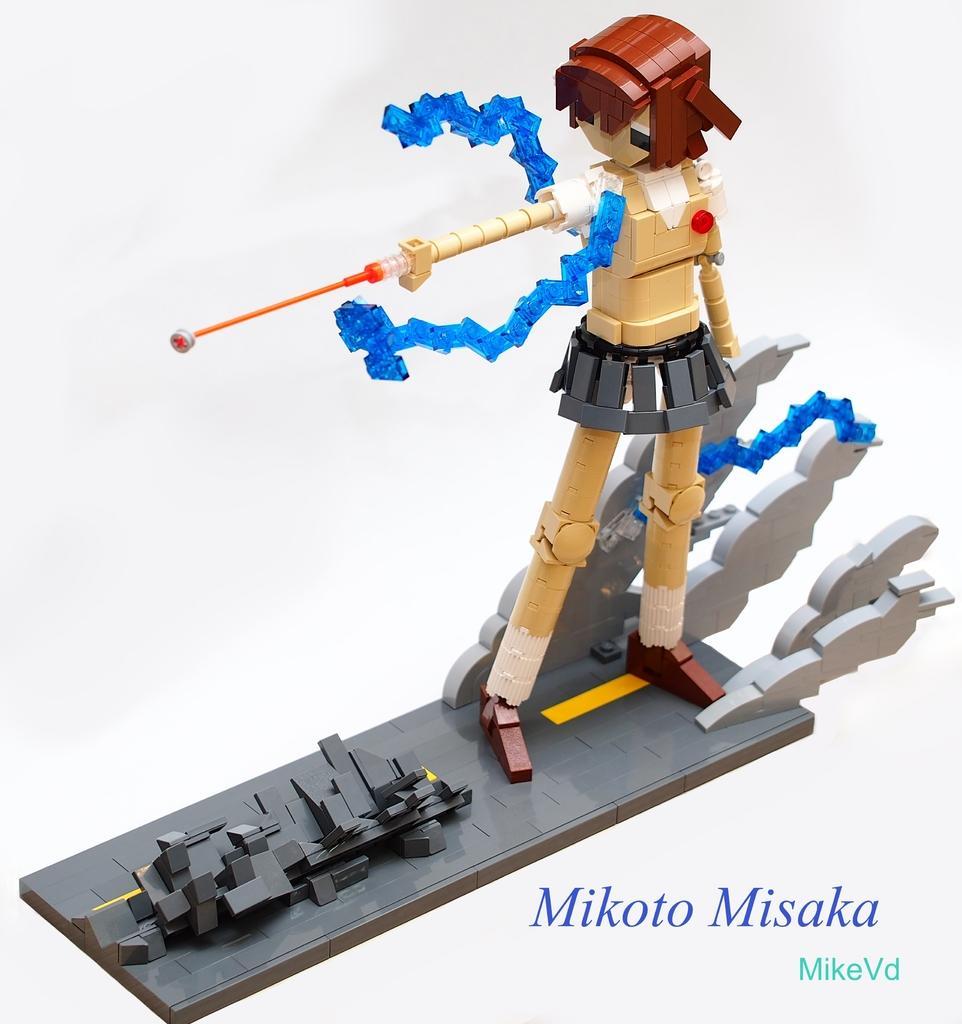Could you give a brief overview of what you see in this image? In this image we can see a toy of a girl. Some text written on the image. 